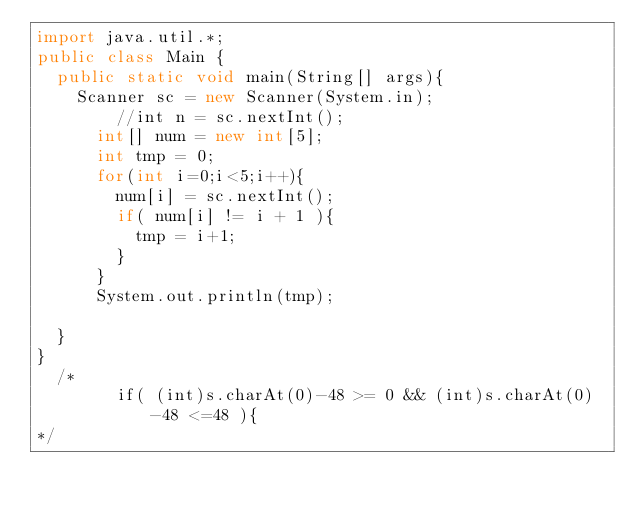<code> <loc_0><loc_0><loc_500><loc_500><_Java_>import java.util.*;
public class Main {
	public static void main(String[] args){
		Scanner sc = new Scanner(System.in);
      	//int n = sc.nextInt();
      int[] num = new int[5];
      int tmp = 0;
      for(int i=0;i<5;i++){
        num[i] = sc.nextInt();
        if( num[i] != i + 1 ){
          tmp = i+1;
        }
      }
      System.out.println(tmp);
      
	}
}
  /*
        if( (int)s.charAt(0)-48 >= 0 && (int)s.charAt(0)-48 <=48 ){
*/</code> 